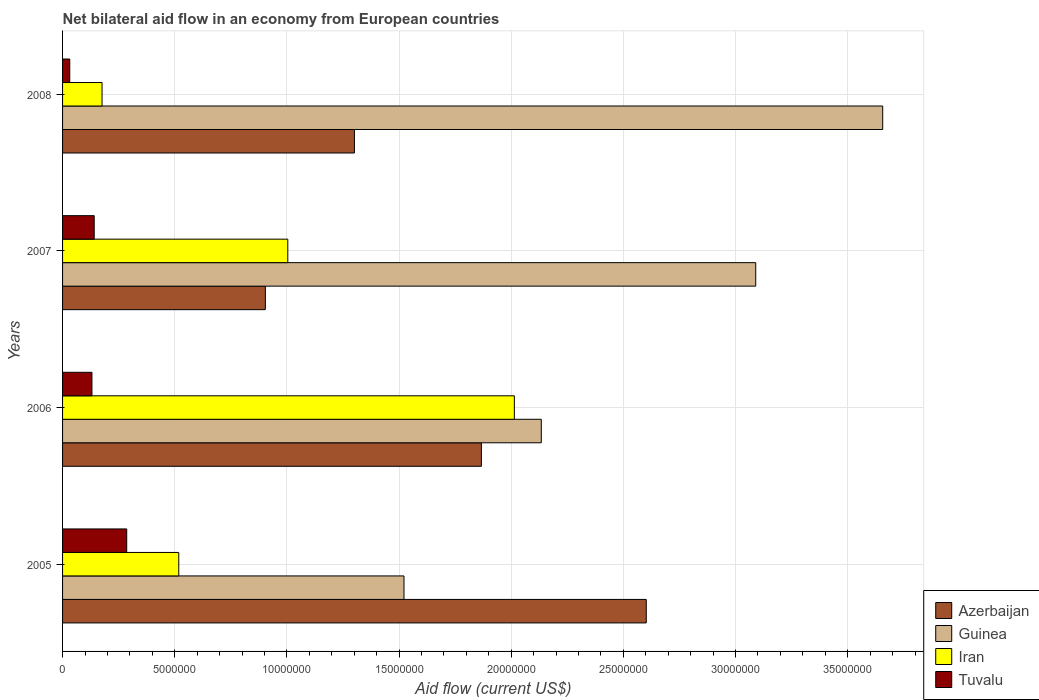How many groups of bars are there?
Offer a very short reply. 4. Are the number of bars on each tick of the Y-axis equal?
Your answer should be compact. Yes. How many bars are there on the 1st tick from the bottom?
Your answer should be very brief. 4. In how many cases, is the number of bars for a given year not equal to the number of legend labels?
Make the answer very short. 0. What is the net bilateral aid flow in Azerbaijan in 2007?
Your answer should be very brief. 9.04e+06. Across all years, what is the maximum net bilateral aid flow in Tuvalu?
Give a very brief answer. 2.86e+06. Across all years, what is the minimum net bilateral aid flow in Azerbaijan?
Your response must be concise. 9.04e+06. What is the total net bilateral aid flow in Azerbaijan in the graph?
Give a very brief answer. 6.67e+07. What is the difference between the net bilateral aid flow in Iran in 2007 and that in 2008?
Provide a succinct answer. 8.28e+06. What is the difference between the net bilateral aid flow in Guinea in 2006 and the net bilateral aid flow in Iran in 2005?
Provide a short and direct response. 1.62e+07. What is the average net bilateral aid flow in Guinea per year?
Provide a short and direct response. 2.60e+07. In the year 2006, what is the difference between the net bilateral aid flow in Tuvalu and net bilateral aid flow in Iran?
Your response must be concise. -1.88e+07. In how many years, is the net bilateral aid flow in Tuvalu greater than 25000000 US$?
Ensure brevity in your answer.  0. What is the ratio of the net bilateral aid flow in Guinea in 2007 to that in 2008?
Provide a short and direct response. 0.85. What is the difference between the highest and the second highest net bilateral aid flow in Tuvalu?
Give a very brief answer. 1.45e+06. What is the difference between the highest and the lowest net bilateral aid flow in Iran?
Your answer should be very brief. 1.84e+07. What does the 4th bar from the top in 2008 represents?
Ensure brevity in your answer.  Azerbaijan. What does the 1st bar from the bottom in 2005 represents?
Keep it short and to the point. Azerbaijan. How many bars are there?
Provide a short and direct response. 16. Are all the bars in the graph horizontal?
Offer a very short reply. Yes. How many years are there in the graph?
Offer a terse response. 4. What is the difference between two consecutive major ticks on the X-axis?
Make the answer very short. 5.00e+06. How many legend labels are there?
Keep it short and to the point. 4. What is the title of the graph?
Your answer should be very brief. Net bilateral aid flow in an economy from European countries. Does "Pacific island small states" appear as one of the legend labels in the graph?
Your response must be concise. No. What is the label or title of the X-axis?
Make the answer very short. Aid flow (current US$). What is the label or title of the Y-axis?
Give a very brief answer. Years. What is the Aid flow (current US$) in Azerbaijan in 2005?
Provide a succinct answer. 2.60e+07. What is the Aid flow (current US$) of Guinea in 2005?
Your answer should be compact. 1.52e+07. What is the Aid flow (current US$) of Iran in 2005?
Offer a very short reply. 5.18e+06. What is the Aid flow (current US$) of Tuvalu in 2005?
Your response must be concise. 2.86e+06. What is the Aid flow (current US$) of Azerbaijan in 2006?
Make the answer very short. 1.87e+07. What is the Aid flow (current US$) in Guinea in 2006?
Ensure brevity in your answer.  2.13e+07. What is the Aid flow (current US$) in Iran in 2006?
Your answer should be very brief. 2.01e+07. What is the Aid flow (current US$) of Tuvalu in 2006?
Keep it short and to the point. 1.31e+06. What is the Aid flow (current US$) in Azerbaijan in 2007?
Your response must be concise. 9.04e+06. What is the Aid flow (current US$) of Guinea in 2007?
Provide a succinct answer. 3.09e+07. What is the Aid flow (current US$) of Iran in 2007?
Your response must be concise. 1.00e+07. What is the Aid flow (current US$) of Tuvalu in 2007?
Offer a very short reply. 1.41e+06. What is the Aid flow (current US$) of Azerbaijan in 2008?
Ensure brevity in your answer.  1.30e+07. What is the Aid flow (current US$) in Guinea in 2008?
Provide a succinct answer. 3.66e+07. What is the Aid flow (current US$) of Iran in 2008?
Keep it short and to the point. 1.76e+06. Across all years, what is the maximum Aid flow (current US$) in Azerbaijan?
Give a very brief answer. 2.60e+07. Across all years, what is the maximum Aid flow (current US$) of Guinea?
Offer a very short reply. 3.66e+07. Across all years, what is the maximum Aid flow (current US$) of Iran?
Offer a terse response. 2.01e+07. Across all years, what is the maximum Aid flow (current US$) in Tuvalu?
Keep it short and to the point. 2.86e+06. Across all years, what is the minimum Aid flow (current US$) in Azerbaijan?
Offer a terse response. 9.04e+06. Across all years, what is the minimum Aid flow (current US$) in Guinea?
Provide a short and direct response. 1.52e+07. Across all years, what is the minimum Aid flow (current US$) in Iran?
Your response must be concise. 1.76e+06. What is the total Aid flow (current US$) in Azerbaijan in the graph?
Provide a succinct answer. 6.67e+07. What is the total Aid flow (current US$) of Guinea in the graph?
Make the answer very short. 1.04e+08. What is the total Aid flow (current US$) of Iran in the graph?
Your response must be concise. 3.71e+07. What is the total Aid flow (current US$) of Tuvalu in the graph?
Provide a succinct answer. 5.90e+06. What is the difference between the Aid flow (current US$) of Azerbaijan in 2005 and that in 2006?
Keep it short and to the point. 7.35e+06. What is the difference between the Aid flow (current US$) in Guinea in 2005 and that in 2006?
Provide a succinct answer. -6.12e+06. What is the difference between the Aid flow (current US$) of Iran in 2005 and that in 2006?
Make the answer very short. -1.50e+07. What is the difference between the Aid flow (current US$) in Tuvalu in 2005 and that in 2006?
Give a very brief answer. 1.55e+06. What is the difference between the Aid flow (current US$) of Azerbaijan in 2005 and that in 2007?
Your answer should be compact. 1.70e+07. What is the difference between the Aid flow (current US$) in Guinea in 2005 and that in 2007?
Offer a terse response. -1.57e+07. What is the difference between the Aid flow (current US$) of Iran in 2005 and that in 2007?
Provide a short and direct response. -4.86e+06. What is the difference between the Aid flow (current US$) in Tuvalu in 2005 and that in 2007?
Make the answer very short. 1.45e+06. What is the difference between the Aid flow (current US$) in Azerbaijan in 2005 and that in 2008?
Offer a very short reply. 1.30e+07. What is the difference between the Aid flow (current US$) of Guinea in 2005 and that in 2008?
Give a very brief answer. -2.13e+07. What is the difference between the Aid flow (current US$) in Iran in 2005 and that in 2008?
Offer a very short reply. 3.42e+06. What is the difference between the Aid flow (current US$) of Tuvalu in 2005 and that in 2008?
Keep it short and to the point. 2.54e+06. What is the difference between the Aid flow (current US$) in Azerbaijan in 2006 and that in 2007?
Keep it short and to the point. 9.63e+06. What is the difference between the Aid flow (current US$) in Guinea in 2006 and that in 2007?
Your answer should be compact. -9.56e+06. What is the difference between the Aid flow (current US$) of Iran in 2006 and that in 2007?
Your response must be concise. 1.01e+07. What is the difference between the Aid flow (current US$) of Azerbaijan in 2006 and that in 2008?
Make the answer very short. 5.66e+06. What is the difference between the Aid flow (current US$) of Guinea in 2006 and that in 2008?
Your answer should be very brief. -1.52e+07. What is the difference between the Aid flow (current US$) of Iran in 2006 and that in 2008?
Make the answer very short. 1.84e+07. What is the difference between the Aid flow (current US$) of Tuvalu in 2006 and that in 2008?
Keep it short and to the point. 9.90e+05. What is the difference between the Aid flow (current US$) of Azerbaijan in 2007 and that in 2008?
Offer a very short reply. -3.97e+06. What is the difference between the Aid flow (current US$) in Guinea in 2007 and that in 2008?
Give a very brief answer. -5.66e+06. What is the difference between the Aid flow (current US$) of Iran in 2007 and that in 2008?
Your answer should be very brief. 8.28e+06. What is the difference between the Aid flow (current US$) in Tuvalu in 2007 and that in 2008?
Offer a terse response. 1.09e+06. What is the difference between the Aid flow (current US$) in Azerbaijan in 2005 and the Aid flow (current US$) in Guinea in 2006?
Ensure brevity in your answer.  4.68e+06. What is the difference between the Aid flow (current US$) in Azerbaijan in 2005 and the Aid flow (current US$) in Iran in 2006?
Provide a short and direct response. 5.88e+06. What is the difference between the Aid flow (current US$) of Azerbaijan in 2005 and the Aid flow (current US$) of Tuvalu in 2006?
Ensure brevity in your answer.  2.47e+07. What is the difference between the Aid flow (current US$) of Guinea in 2005 and the Aid flow (current US$) of Iran in 2006?
Your answer should be very brief. -4.92e+06. What is the difference between the Aid flow (current US$) in Guinea in 2005 and the Aid flow (current US$) in Tuvalu in 2006?
Offer a very short reply. 1.39e+07. What is the difference between the Aid flow (current US$) in Iran in 2005 and the Aid flow (current US$) in Tuvalu in 2006?
Give a very brief answer. 3.87e+06. What is the difference between the Aid flow (current US$) in Azerbaijan in 2005 and the Aid flow (current US$) in Guinea in 2007?
Offer a very short reply. -4.88e+06. What is the difference between the Aid flow (current US$) in Azerbaijan in 2005 and the Aid flow (current US$) in Iran in 2007?
Provide a short and direct response. 1.60e+07. What is the difference between the Aid flow (current US$) in Azerbaijan in 2005 and the Aid flow (current US$) in Tuvalu in 2007?
Offer a very short reply. 2.46e+07. What is the difference between the Aid flow (current US$) in Guinea in 2005 and the Aid flow (current US$) in Iran in 2007?
Ensure brevity in your answer.  5.18e+06. What is the difference between the Aid flow (current US$) of Guinea in 2005 and the Aid flow (current US$) of Tuvalu in 2007?
Provide a succinct answer. 1.38e+07. What is the difference between the Aid flow (current US$) in Iran in 2005 and the Aid flow (current US$) in Tuvalu in 2007?
Provide a succinct answer. 3.77e+06. What is the difference between the Aid flow (current US$) in Azerbaijan in 2005 and the Aid flow (current US$) in Guinea in 2008?
Make the answer very short. -1.05e+07. What is the difference between the Aid flow (current US$) in Azerbaijan in 2005 and the Aid flow (current US$) in Iran in 2008?
Your response must be concise. 2.43e+07. What is the difference between the Aid flow (current US$) in Azerbaijan in 2005 and the Aid flow (current US$) in Tuvalu in 2008?
Provide a succinct answer. 2.57e+07. What is the difference between the Aid flow (current US$) of Guinea in 2005 and the Aid flow (current US$) of Iran in 2008?
Ensure brevity in your answer.  1.35e+07. What is the difference between the Aid flow (current US$) in Guinea in 2005 and the Aid flow (current US$) in Tuvalu in 2008?
Provide a succinct answer. 1.49e+07. What is the difference between the Aid flow (current US$) of Iran in 2005 and the Aid flow (current US$) of Tuvalu in 2008?
Ensure brevity in your answer.  4.86e+06. What is the difference between the Aid flow (current US$) of Azerbaijan in 2006 and the Aid flow (current US$) of Guinea in 2007?
Make the answer very short. -1.22e+07. What is the difference between the Aid flow (current US$) of Azerbaijan in 2006 and the Aid flow (current US$) of Iran in 2007?
Your answer should be compact. 8.63e+06. What is the difference between the Aid flow (current US$) of Azerbaijan in 2006 and the Aid flow (current US$) of Tuvalu in 2007?
Ensure brevity in your answer.  1.73e+07. What is the difference between the Aid flow (current US$) of Guinea in 2006 and the Aid flow (current US$) of Iran in 2007?
Make the answer very short. 1.13e+07. What is the difference between the Aid flow (current US$) in Guinea in 2006 and the Aid flow (current US$) in Tuvalu in 2007?
Offer a terse response. 1.99e+07. What is the difference between the Aid flow (current US$) in Iran in 2006 and the Aid flow (current US$) in Tuvalu in 2007?
Provide a short and direct response. 1.87e+07. What is the difference between the Aid flow (current US$) in Azerbaijan in 2006 and the Aid flow (current US$) in Guinea in 2008?
Offer a terse response. -1.79e+07. What is the difference between the Aid flow (current US$) of Azerbaijan in 2006 and the Aid flow (current US$) of Iran in 2008?
Give a very brief answer. 1.69e+07. What is the difference between the Aid flow (current US$) of Azerbaijan in 2006 and the Aid flow (current US$) of Tuvalu in 2008?
Offer a terse response. 1.84e+07. What is the difference between the Aid flow (current US$) in Guinea in 2006 and the Aid flow (current US$) in Iran in 2008?
Ensure brevity in your answer.  1.96e+07. What is the difference between the Aid flow (current US$) of Guinea in 2006 and the Aid flow (current US$) of Tuvalu in 2008?
Make the answer very short. 2.10e+07. What is the difference between the Aid flow (current US$) of Iran in 2006 and the Aid flow (current US$) of Tuvalu in 2008?
Your answer should be compact. 1.98e+07. What is the difference between the Aid flow (current US$) of Azerbaijan in 2007 and the Aid flow (current US$) of Guinea in 2008?
Ensure brevity in your answer.  -2.75e+07. What is the difference between the Aid flow (current US$) in Azerbaijan in 2007 and the Aid flow (current US$) in Iran in 2008?
Give a very brief answer. 7.28e+06. What is the difference between the Aid flow (current US$) of Azerbaijan in 2007 and the Aid flow (current US$) of Tuvalu in 2008?
Your response must be concise. 8.72e+06. What is the difference between the Aid flow (current US$) in Guinea in 2007 and the Aid flow (current US$) in Iran in 2008?
Your answer should be compact. 2.91e+07. What is the difference between the Aid flow (current US$) of Guinea in 2007 and the Aid flow (current US$) of Tuvalu in 2008?
Keep it short and to the point. 3.06e+07. What is the difference between the Aid flow (current US$) of Iran in 2007 and the Aid flow (current US$) of Tuvalu in 2008?
Your answer should be compact. 9.72e+06. What is the average Aid flow (current US$) of Azerbaijan per year?
Keep it short and to the point. 1.67e+07. What is the average Aid flow (current US$) of Guinea per year?
Your answer should be very brief. 2.60e+07. What is the average Aid flow (current US$) of Iran per year?
Your answer should be very brief. 9.28e+06. What is the average Aid flow (current US$) in Tuvalu per year?
Make the answer very short. 1.48e+06. In the year 2005, what is the difference between the Aid flow (current US$) in Azerbaijan and Aid flow (current US$) in Guinea?
Keep it short and to the point. 1.08e+07. In the year 2005, what is the difference between the Aid flow (current US$) of Azerbaijan and Aid flow (current US$) of Iran?
Your answer should be compact. 2.08e+07. In the year 2005, what is the difference between the Aid flow (current US$) of Azerbaijan and Aid flow (current US$) of Tuvalu?
Provide a short and direct response. 2.32e+07. In the year 2005, what is the difference between the Aid flow (current US$) of Guinea and Aid flow (current US$) of Iran?
Your answer should be very brief. 1.00e+07. In the year 2005, what is the difference between the Aid flow (current US$) of Guinea and Aid flow (current US$) of Tuvalu?
Provide a succinct answer. 1.24e+07. In the year 2005, what is the difference between the Aid flow (current US$) in Iran and Aid flow (current US$) in Tuvalu?
Your answer should be compact. 2.32e+06. In the year 2006, what is the difference between the Aid flow (current US$) in Azerbaijan and Aid flow (current US$) in Guinea?
Your answer should be very brief. -2.67e+06. In the year 2006, what is the difference between the Aid flow (current US$) of Azerbaijan and Aid flow (current US$) of Iran?
Offer a very short reply. -1.47e+06. In the year 2006, what is the difference between the Aid flow (current US$) in Azerbaijan and Aid flow (current US$) in Tuvalu?
Ensure brevity in your answer.  1.74e+07. In the year 2006, what is the difference between the Aid flow (current US$) of Guinea and Aid flow (current US$) of Iran?
Your answer should be very brief. 1.20e+06. In the year 2006, what is the difference between the Aid flow (current US$) of Guinea and Aid flow (current US$) of Tuvalu?
Offer a terse response. 2.00e+07. In the year 2006, what is the difference between the Aid flow (current US$) in Iran and Aid flow (current US$) in Tuvalu?
Ensure brevity in your answer.  1.88e+07. In the year 2007, what is the difference between the Aid flow (current US$) in Azerbaijan and Aid flow (current US$) in Guinea?
Make the answer very short. -2.19e+07. In the year 2007, what is the difference between the Aid flow (current US$) of Azerbaijan and Aid flow (current US$) of Tuvalu?
Your response must be concise. 7.63e+06. In the year 2007, what is the difference between the Aid flow (current US$) of Guinea and Aid flow (current US$) of Iran?
Provide a short and direct response. 2.09e+07. In the year 2007, what is the difference between the Aid flow (current US$) in Guinea and Aid flow (current US$) in Tuvalu?
Ensure brevity in your answer.  2.95e+07. In the year 2007, what is the difference between the Aid flow (current US$) in Iran and Aid flow (current US$) in Tuvalu?
Make the answer very short. 8.63e+06. In the year 2008, what is the difference between the Aid flow (current US$) of Azerbaijan and Aid flow (current US$) of Guinea?
Provide a short and direct response. -2.36e+07. In the year 2008, what is the difference between the Aid flow (current US$) of Azerbaijan and Aid flow (current US$) of Iran?
Your response must be concise. 1.12e+07. In the year 2008, what is the difference between the Aid flow (current US$) in Azerbaijan and Aid flow (current US$) in Tuvalu?
Your answer should be very brief. 1.27e+07. In the year 2008, what is the difference between the Aid flow (current US$) in Guinea and Aid flow (current US$) in Iran?
Provide a short and direct response. 3.48e+07. In the year 2008, what is the difference between the Aid flow (current US$) in Guinea and Aid flow (current US$) in Tuvalu?
Your response must be concise. 3.62e+07. In the year 2008, what is the difference between the Aid flow (current US$) in Iran and Aid flow (current US$) in Tuvalu?
Provide a short and direct response. 1.44e+06. What is the ratio of the Aid flow (current US$) in Azerbaijan in 2005 to that in 2006?
Make the answer very short. 1.39. What is the ratio of the Aid flow (current US$) of Guinea in 2005 to that in 2006?
Make the answer very short. 0.71. What is the ratio of the Aid flow (current US$) of Iran in 2005 to that in 2006?
Provide a short and direct response. 0.26. What is the ratio of the Aid flow (current US$) in Tuvalu in 2005 to that in 2006?
Your answer should be very brief. 2.18. What is the ratio of the Aid flow (current US$) in Azerbaijan in 2005 to that in 2007?
Keep it short and to the point. 2.88. What is the ratio of the Aid flow (current US$) of Guinea in 2005 to that in 2007?
Give a very brief answer. 0.49. What is the ratio of the Aid flow (current US$) in Iran in 2005 to that in 2007?
Your answer should be compact. 0.52. What is the ratio of the Aid flow (current US$) in Tuvalu in 2005 to that in 2007?
Keep it short and to the point. 2.03. What is the ratio of the Aid flow (current US$) of Azerbaijan in 2005 to that in 2008?
Keep it short and to the point. 2. What is the ratio of the Aid flow (current US$) in Guinea in 2005 to that in 2008?
Your answer should be compact. 0.42. What is the ratio of the Aid flow (current US$) in Iran in 2005 to that in 2008?
Offer a terse response. 2.94. What is the ratio of the Aid flow (current US$) of Tuvalu in 2005 to that in 2008?
Your response must be concise. 8.94. What is the ratio of the Aid flow (current US$) of Azerbaijan in 2006 to that in 2007?
Your answer should be very brief. 2.07. What is the ratio of the Aid flow (current US$) in Guinea in 2006 to that in 2007?
Offer a very short reply. 0.69. What is the ratio of the Aid flow (current US$) of Iran in 2006 to that in 2007?
Make the answer very short. 2.01. What is the ratio of the Aid flow (current US$) in Tuvalu in 2006 to that in 2007?
Provide a short and direct response. 0.93. What is the ratio of the Aid flow (current US$) in Azerbaijan in 2006 to that in 2008?
Your answer should be compact. 1.44. What is the ratio of the Aid flow (current US$) of Guinea in 2006 to that in 2008?
Your response must be concise. 0.58. What is the ratio of the Aid flow (current US$) of Iran in 2006 to that in 2008?
Offer a terse response. 11.44. What is the ratio of the Aid flow (current US$) of Tuvalu in 2006 to that in 2008?
Ensure brevity in your answer.  4.09. What is the ratio of the Aid flow (current US$) in Azerbaijan in 2007 to that in 2008?
Your answer should be very brief. 0.69. What is the ratio of the Aid flow (current US$) of Guinea in 2007 to that in 2008?
Make the answer very short. 0.85. What is the ratio of the Aid flow (current US$) in Iran in 2007 to that in 2008?
Ensure brevity in your answer.  5.7. What is the ratio of the Aid flow (current US$) in Tuvalu in 2007 to that in 2008?
Give a very brief answer. 4.41. What is the difference between the highest and the second highest Aid flow (current US$) in Azerbaijan?
Make the answer very short. 7.35e+06. What is the difference between the highest and the second highest Aid flow (current US$) of Guinea?
Ensure brevity in your answer.  5.66e+06. What is the difference between the highest and the second highest Aid flow (current US$) in Iran?
Provide a short and direct response. 1.01e+07. What is the difference between the highest and the second highest Aid flow (current US$) of Tuvalu?
Offer a very short reply. 1.45e+06. What is the difference between the highest and the lowest Aid flow (current US$) in Azerbaijan?
Keep it short and to the point. 1.70e+07. What is the difference between the highest and the lowest Aid flow (current US$) of Guinea?
Give a very brief answer. 2.13e+07. What is the difference between the highest and the lowest Aid flow (current US$) in Iran?
Provide a short and direct response. 1.84e+07. What is the difference between the highest and the lowest Aid flow (current US$) of Tuvalu?
Provide a succinct answer. 2.54e+06. 